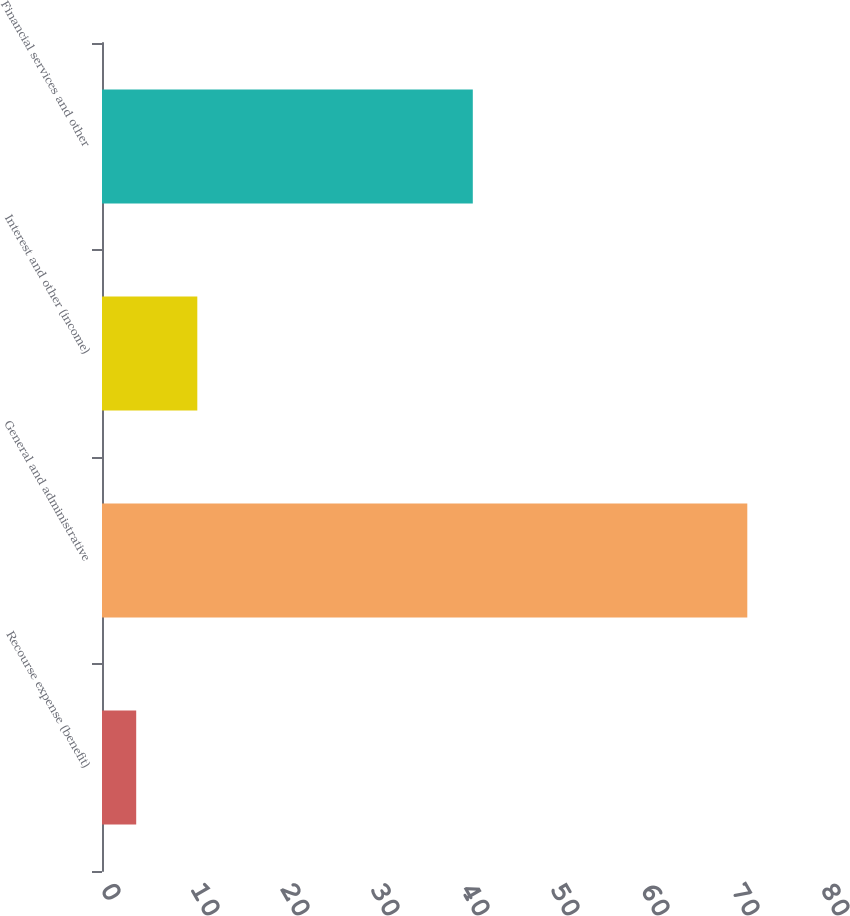Convert chart. <chart><loc_0><loc_0><loc_500><loc_500><bar_chart><fcel>Recourse expense (benefit)<fcel>General and administrative<fcel>Interest and other (income)<fcel>Financial services and other<nl><fcel>3.8<fcel>71.7<fcel>10.59<fcel>41.2<nl></chart> 